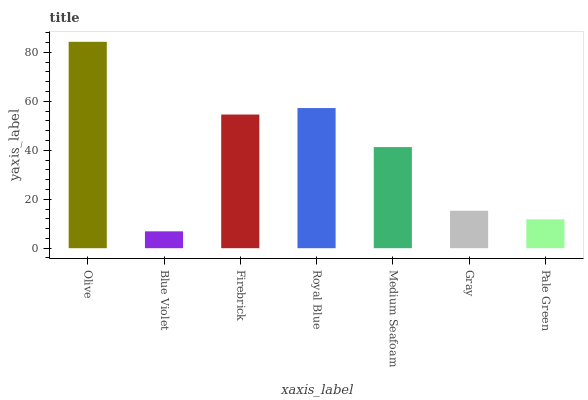Is Firebrick the minimum?
Answer yes or no. No. Is Firebrick the maximum?
Answer yes or no. No. Is Firebrick greater than Blue Violet?
Answer yes or no. Yes. Is Blue Violet less than Firebrick?
Answer yes or no. Yes. Is Blue Violet greater than Firebrick?
Answer yes or no. No. Is Firebrick less than Blue Violet?
Answer yes or no. No. Is Medium Seafoam the high median?
Answer yes or no. Yes. Is Medium Seafoam the low median?
Answer yes or no. Yes. Is Blue Violet the high median?
Answer yes or no. No. Is Blue Violet the low median?
Answer yes or no. No. 